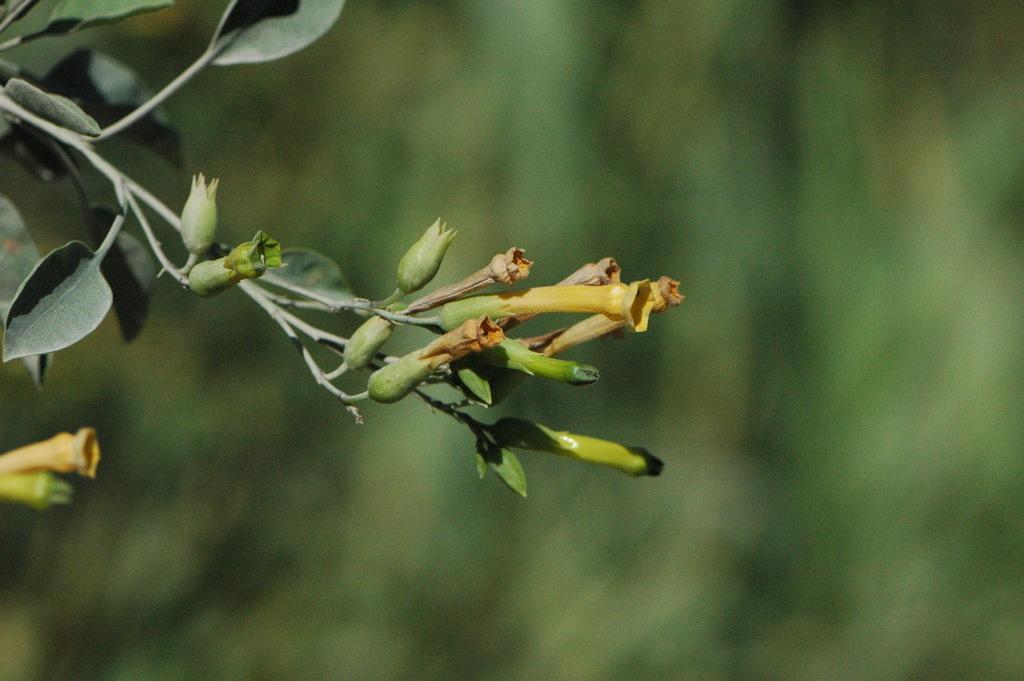Describe this image in one or two sentences. In this image I can see green colour leaves and green buds. I can also see green colour in background and I can see this image is blurry from background. 